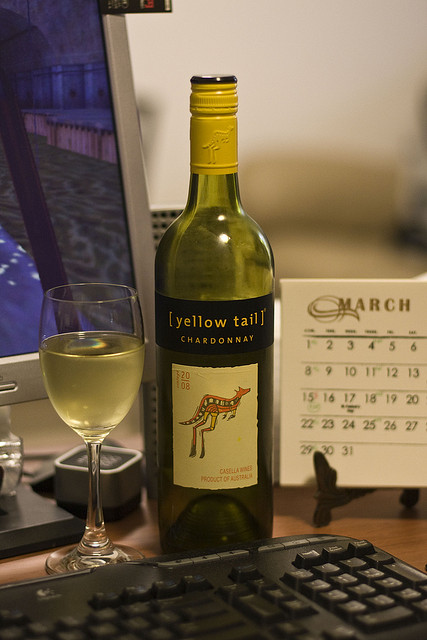Read and extract the text from this image. [ yellow tail 3 CHARDONNAY 20 08 321 30 29 27 26 25 24 23 22 19 18 17 16 15 12 11 10 9 20 13 6 5 4 3 2 1 MARCH 